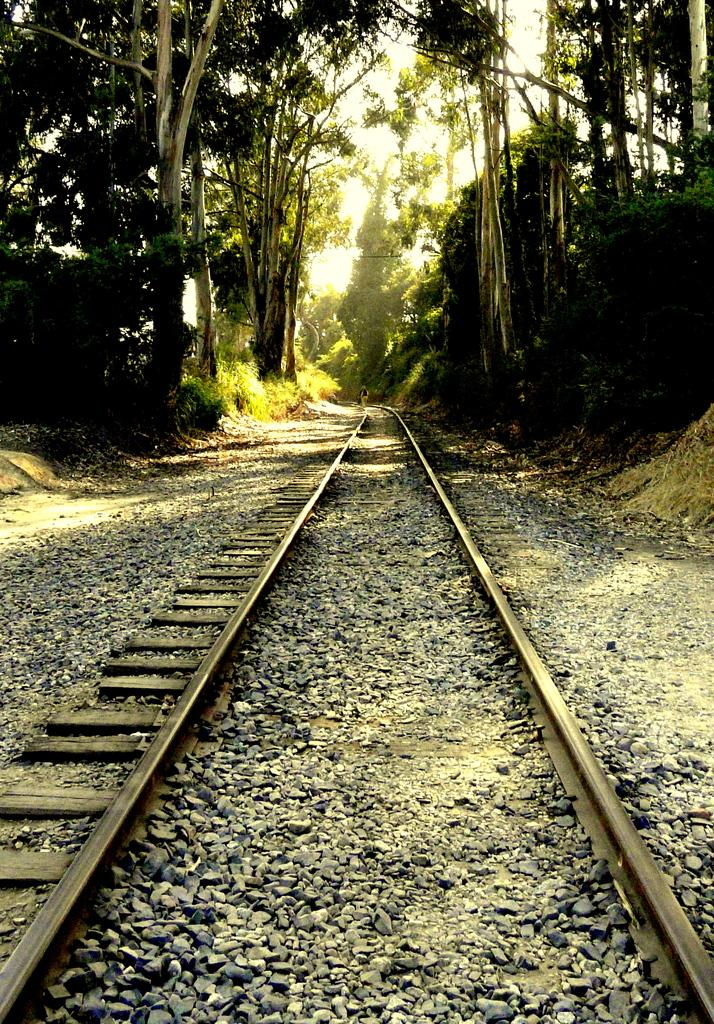What type of transportation infrastructure is present in the image? There is a railway track in the image. What can be seen in the background of the image? Trees are visible at the top of the image, and the sky is also visible. Are there any additional features on the railway track? Yes, there are stones visible on the railway track. Where is the oven located in the image? There is no oven present in the image. Can you describe the dog's behavior in the image? There is no dog present in the image. 